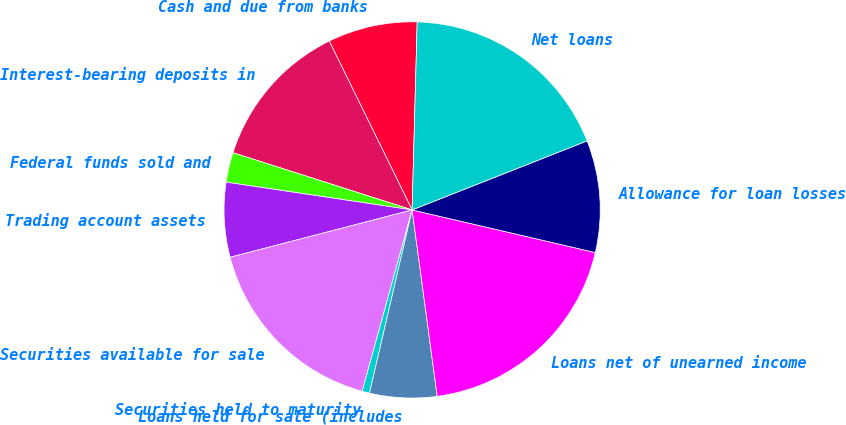Convert chart to OTSL. <chart><loc_0><loc_0><loc_500><loc_500><pie_chart><fcel>Cash and due from banks<fcel>Interest-bearing deposits in<fcel>Federal funds sold and<fcel>Trading account assets<fcel>Securities available for sale<fcel>Securities held to maturity<fcel>Loans held for sale (includes<fcel>Loans net of unearned income<fcel>Allowance for loan losses<fcel>Net loans<nl><fcel>7.69%<fcel>12.82%<fcel>2.56%<fcel>6.41%<fcel>16.67%<fcel>0.64%<fcel>5.77%<fcel>19.23%<fcel>9.62%<fcel>18.59%<nl></chart> 